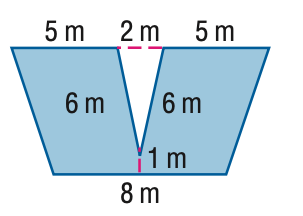Answer the mathemtical geometry problem and directly provide the correct option letter.
Question: Find the area of the figure. Round to the nearest tenth if necessary.
Choices: A: 5.9 B: 57.3 C: 63.2 D: 69.1 C 